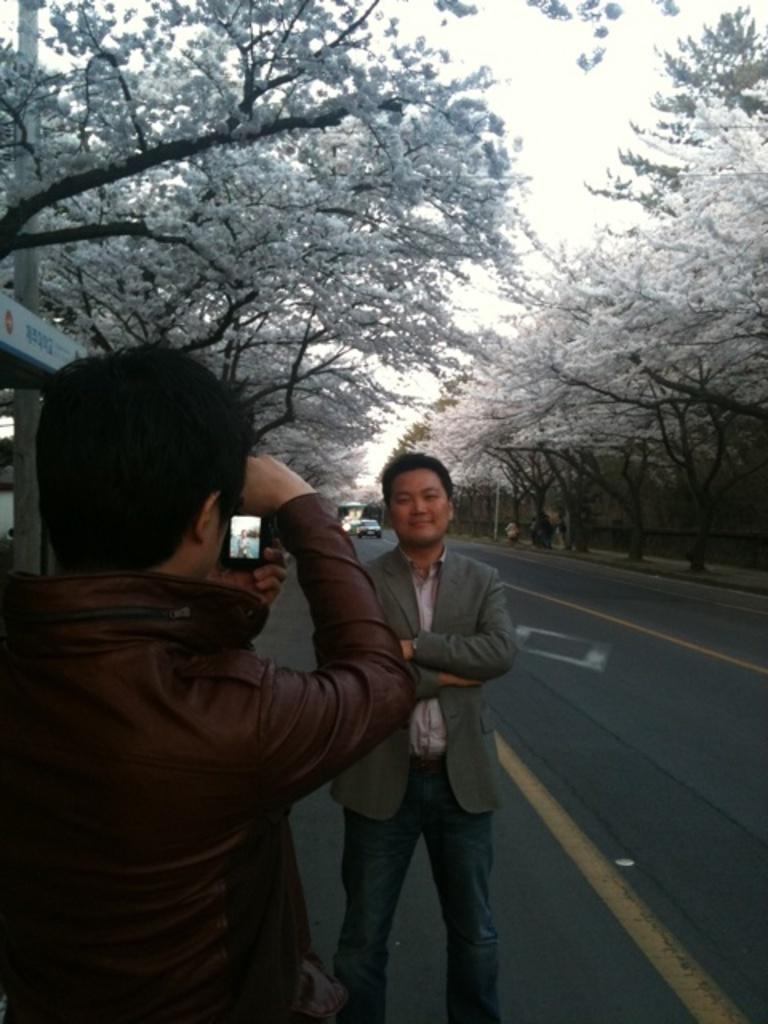In one or two sentences, can you explain what this image depicts? In this picture there is a man standing on the road. In the front there is a boy taking the photo from the camera. Behind there is a road and trees with white flowers. 